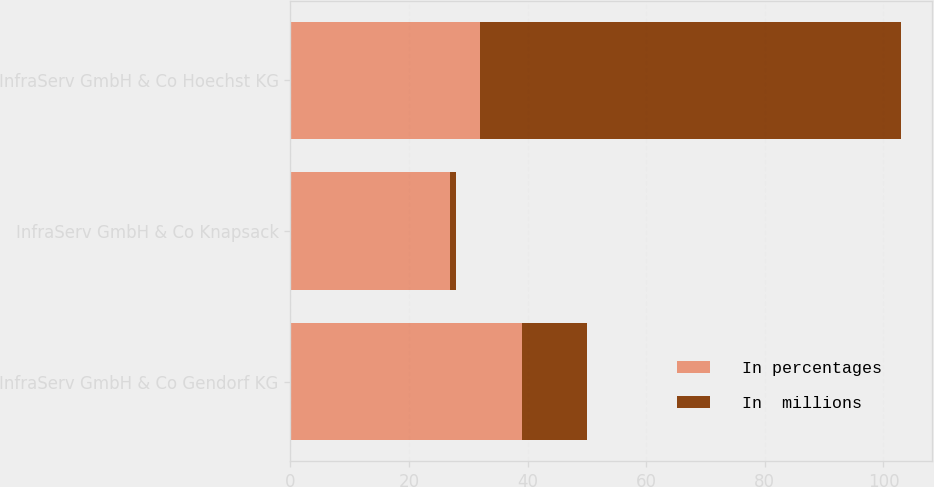Convert chart. <chart><loc_0><loc_0><loc_500><loc_500><stacked_bar_chart><ecel><fcel>InfraServ GmbH & Co Gendorf KG<fcel>InfraServ GmbH & Co Knapsack<fcel>InfraServ GmbH & Co Hoechst KG<nl><fcel>In percentages<fcel>39<fcel>27<fcel>32<nl><fcel>In  millions<fcel>11<fcel>1<fcel>71<nl></chart> 